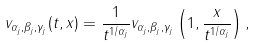Convert formula to latex. <formula><loc_0><loc_0><loc_500><loc_500>v _ { \alpha _ { j } , \beta _ { j } , \gamma _ { j } } ( t , x ) = \frac { 1 } { t ^ { 1 / \alpha _ { j } } } v _ { \alpha _ { j } , \beta _ { j } , \gamma _ { j } } \left ( 1 , \frac { x } { t ^ { 1 / \alpha _ { j } } } \right ) ,</formula> 